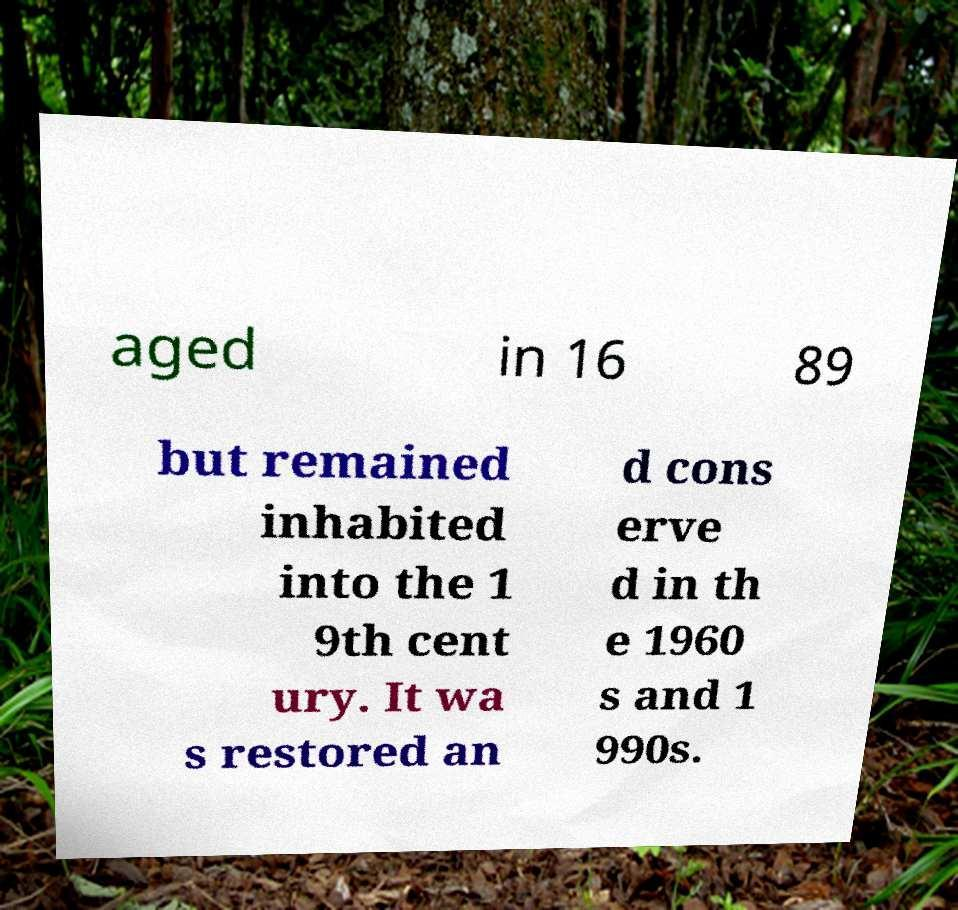Can you accurately transcribe the text from the provided image for me? aged in 16 89 but remained inhabited into the 1 9th cent ury. It wa s restored an d cons erve d in th e 1960 s and 1 990s. 